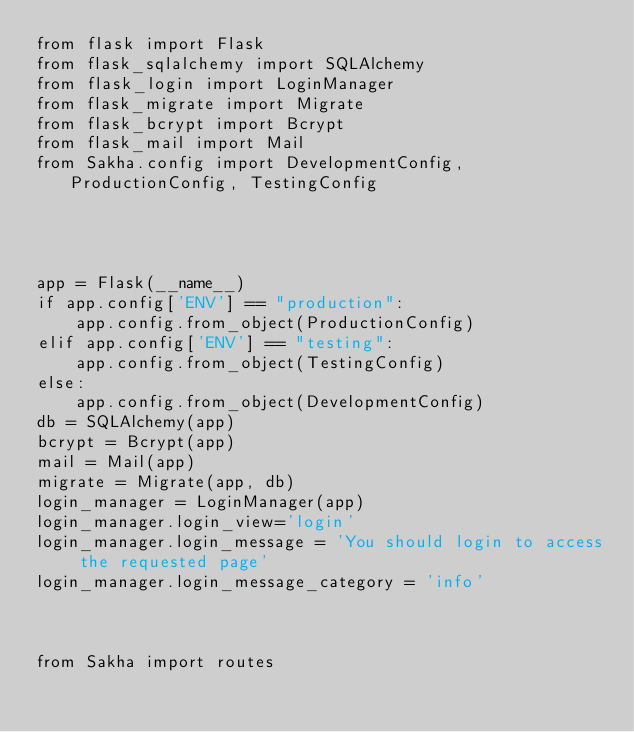Convert code to text. <code><loc_0><loc_0><loc_500><loc_500><_Python_>from flask import Flask
from flask_sqlalchemy import SQLAlchemy
from flask_login import LoginManager
from flask_migrate import Migrate
from flask_bcrypt import Bcrypt
from flask_mail import Mail
from Sakha.config import DevelopmentConfig, ProductionConfig, TestingConfig




app = Flask(__name__)
if app.config['ENV'] == "production":
    app.config.from_object(ProductionConfig)
elif app.config['ENV'] == "testing":
    app.config.from_object(TestingConfig)
else:
    app.config.from_object(DevelopmentConfig)
db = SQLAlchemy(app)
bcrypt = Bcrypt(app)
mail = Mail(app)
migrate = Migrate(app, db)
login_manager = LoginManager(app)
login_manager.login_view='login'
login_manager.login_message = 'You should login to access the requested page'
login_manager.login_message_category = 'info'



from Sakha import routes</code> 